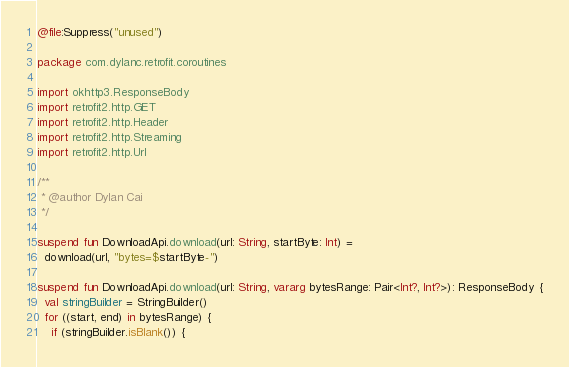<code> <loc_0><loc_0><loc_500><loc_500><_Kotlin_>@file:Suppress("unused")

package com.dylanc.retrofit.coroutines

import okhttp3.ResponseBody
import retrofit2.http.GET
import retrofit2.http.Header
import retrofit2.http.Streaming
import retrofit2.http.Url

/**
 * @author Dylan Cai
 */

suspend fun DownloadApi.download(url: String, startByte: Int) =
  download(url, "bytes=$startByte-")

suspend fun DownloadApi.download(url: String, vararg bytesRange: Pair<Int?, Int?>): ResponseBody {
  val stringBuilder = StringBuilder()
  for ((start, end) in bytesRange) {
    if (stringBuilder.isBlank()) {</code> 